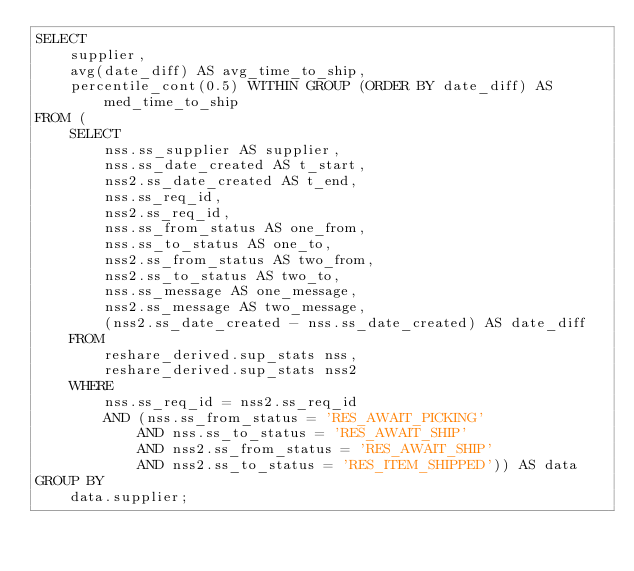Convert code to text. <code><loc_0><loc_0><loc_500><loc_500><_SQL_>SELECT
    supplier,
    avg(date_diff) AS avg_time_to_ship,
    percentile_cont(0.5) WITHIN GROUP (ORDER BY date_diff) AS med_time_to_ship
FROM (
    SELECT
        nss.ss_supplier AS supplier,
        nss.ss_date_created AS t_start,
        nss2.ss_date_created AS t_end,
        nss.ss_req_id,
        nss2.ss_req_id,
        nss.ss_from_status AS one_from,
        nss.ss_to_status AS one_to,
        nss2.ss_from_status AS two_from,
        nss2.ss_to_status AS two_to,
        nss.ss_message AS one_message,
        nss2.ss_message AS two_message,
        (nss2.ss_date_created - nss.ss_date_created) AS date_diff
    FROM
        reshare_derived.sup_stats nss,
        reshare_derived.sup_stats nss2
    WHERE
        nss.ss_req_id = nss2.ss_req_id
        AND (nss.ss_from_status = 'RES_AWAIT_PICKING'
            AND nss.ss_to_status = 'RES_AWAIT_SHIP'
            AND nss2.ss_from_status = 'RES_AWAIT_SHIP'
            AND nss2.ss_to_status = 'RES_ITEM_SHIPPED')) AS data
GROUP BY
    data.supplier;

</code> 